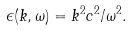Convert formula to latex. <formula><loc_0><loc_0><loc_500><loc_500>\epsilon ( k , \omega ) = k ^ { 2 } c ^ { 2 } / \omega ^ { 2 } .</formula> 